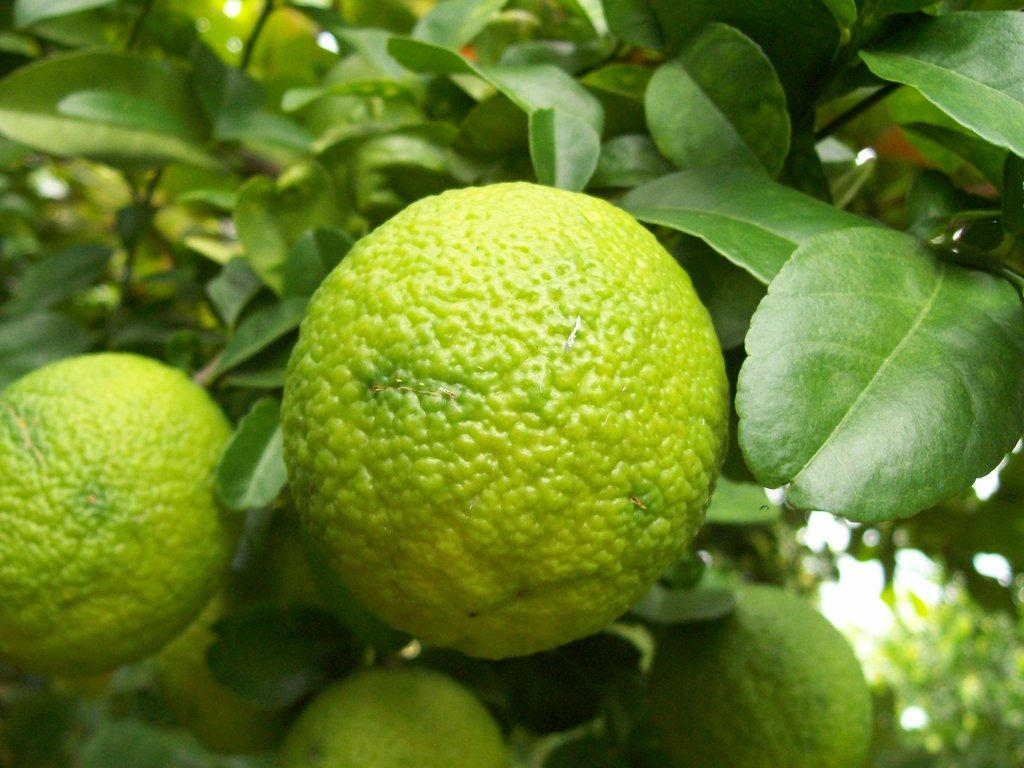What type of objects can be seen in the image? There are fruits in the image. Can you describe the colors of the fruits? The fruits are green and yellow in color. Where are the fruits located? The fruits are on a tree. What can be seen in the background of the image? The sky is visible in the background of the image. What type of doctor can be seen in the image? There is no doctor present in the image; it features fruits on a tree with a visible sky in the background. Can you tell me how many pages are in the image? There are no pages present in the image; it features fruits on a tree with a visible sky in the background. 